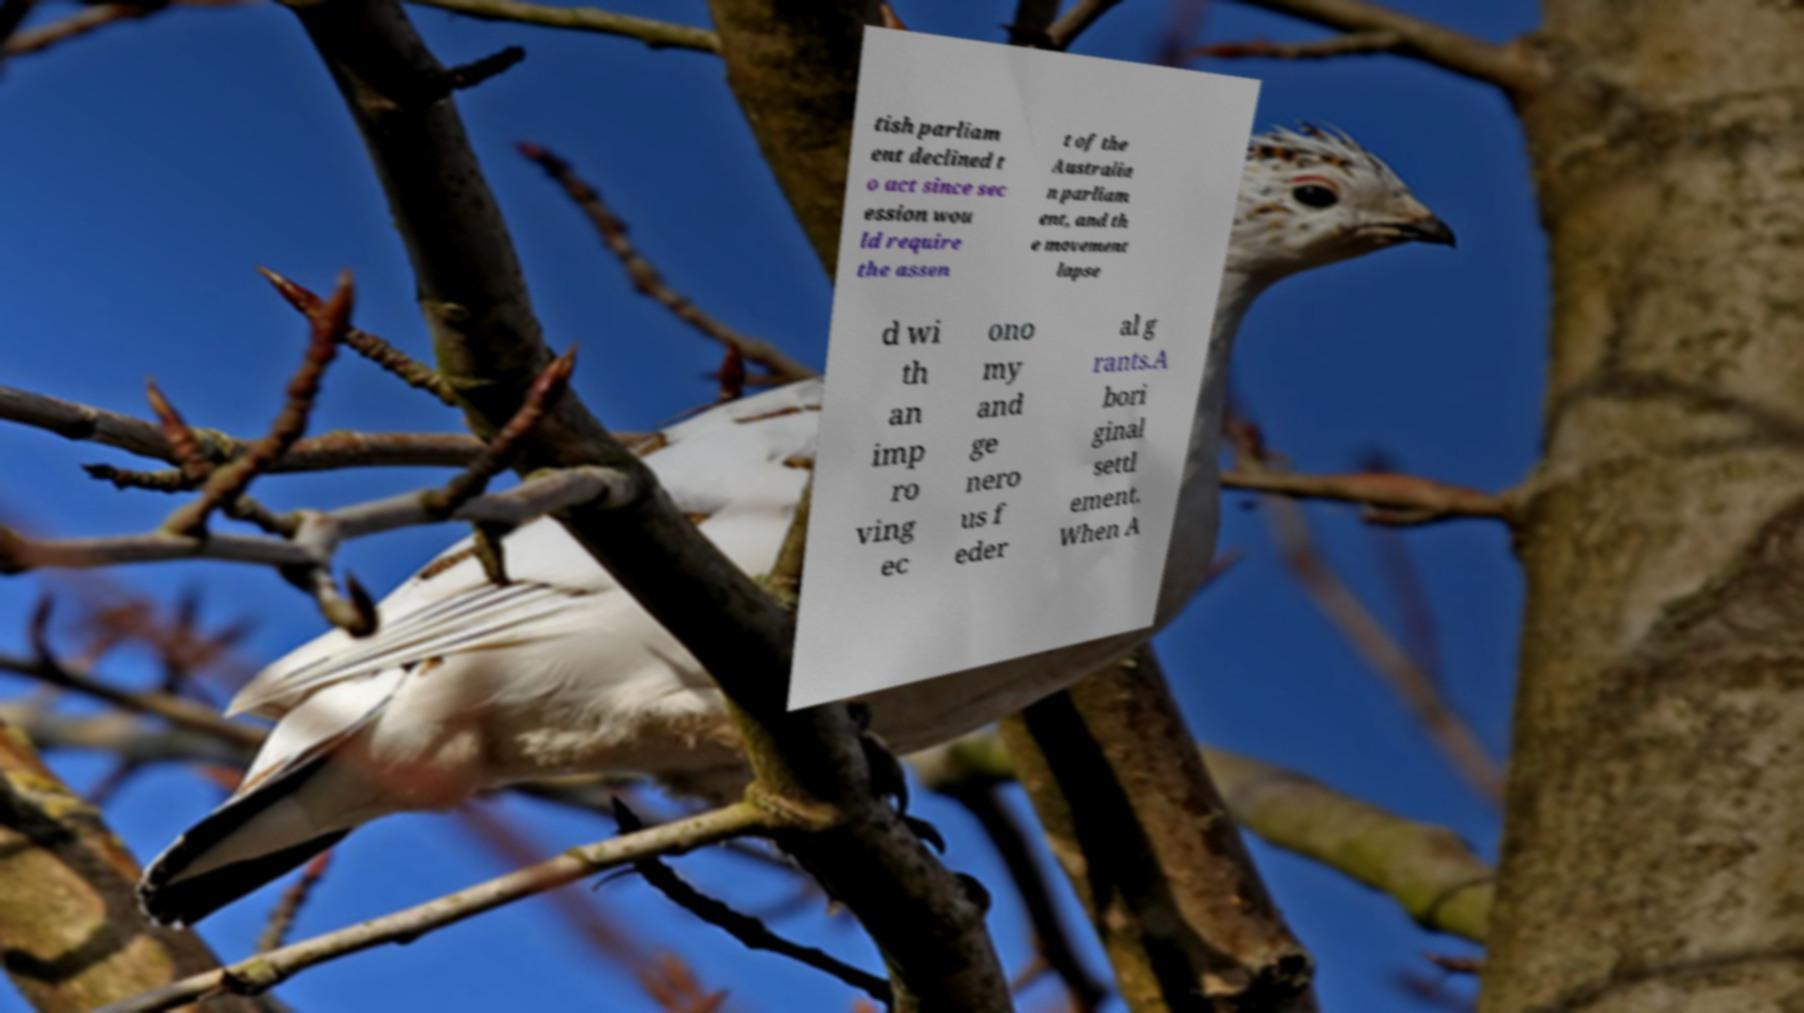There's text embedded in this image that I need extracted. Can you transcribe it verbatim? tish parliam ent declined t o act since sec ession wou ld require the assen t of the Australia n parliam ent, and th e movement lapse d wi th an imp ro ving ec ono my and ge nero us f eder al g rants.A bori ginal settl ement. When A 